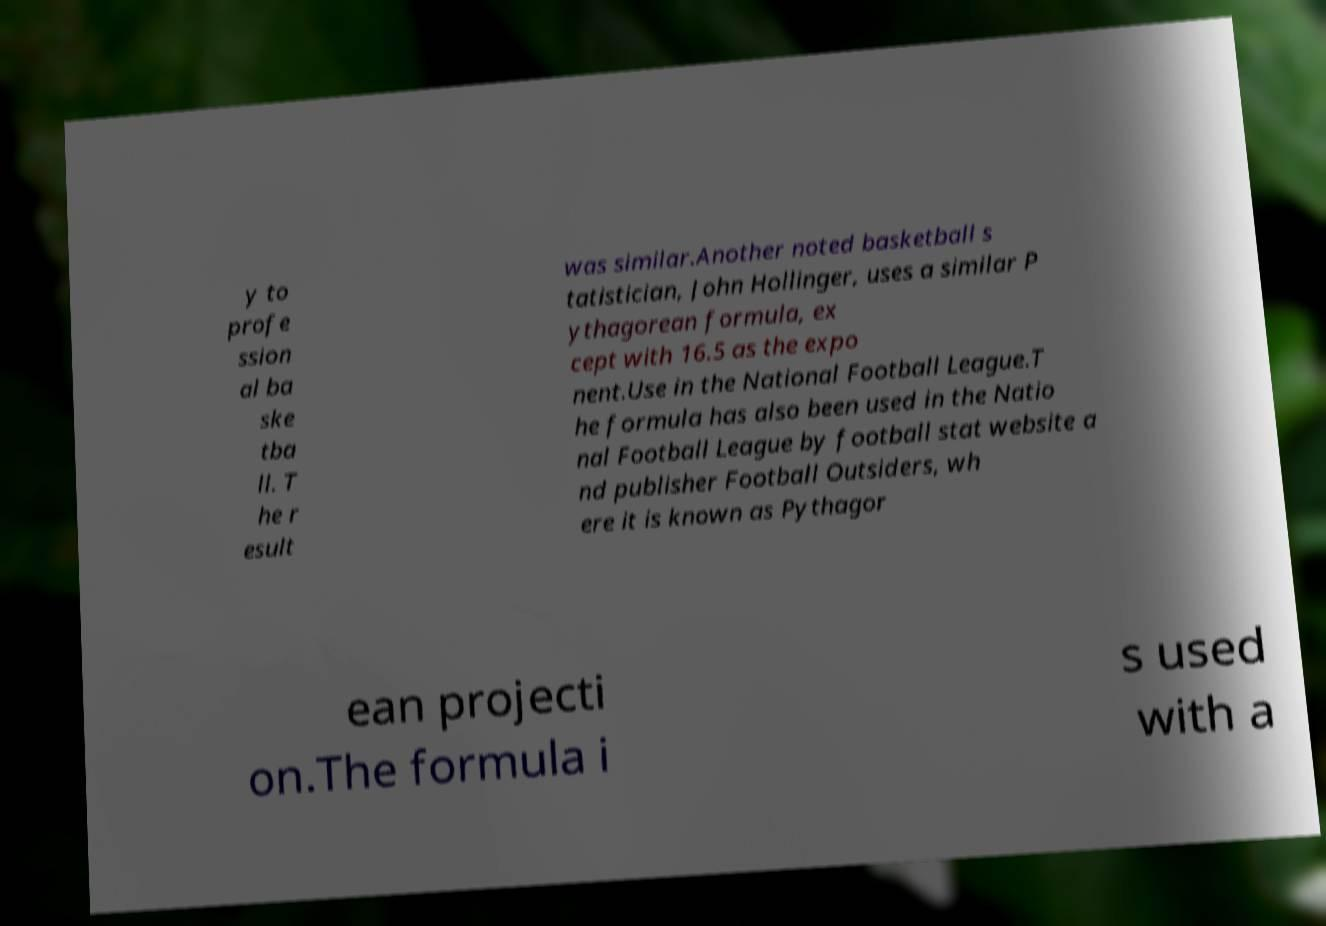There's text embedded in this image that I need extracted. Can you transcribe it verbatim? y to profe ssion al ba ske tba ll. T he r esult was similar.Another noted basketball s tatistician, John Hollinger, uses a similar P ythagorean formula, ex cept with 16.5 as the expo nent.Use in the National Football League.T he formula has also been used in the Natio nal Football League by football stat website a nd publisher Football Outsiders, wh ere it is known as Pythagor ean projecti on.The formula i s used with a 